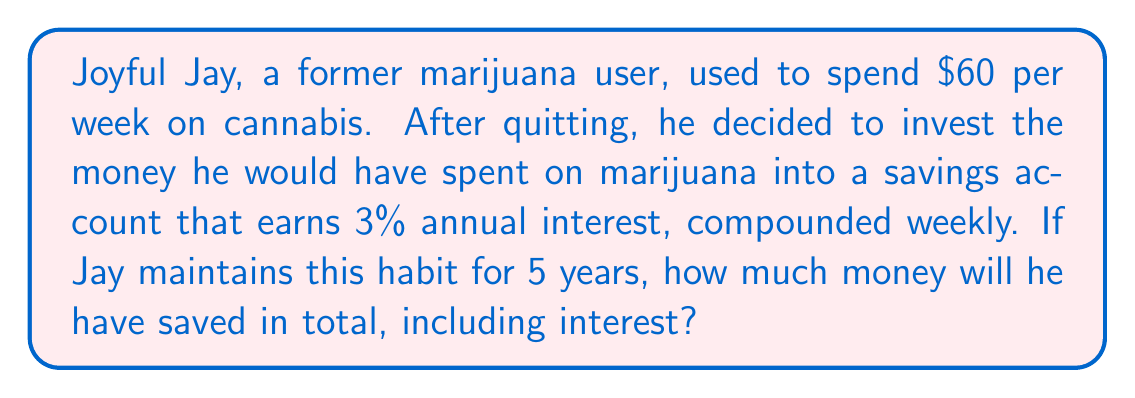Help me with this question. Let's break this problem down step-by-step:

1) First, we need to calculate the weekly savings:
   $60 per week

2) Now, we need to use the compound interest formula:
   $$A = P(1 + \frac{r}{n})^{nt}$$
   Where:
   $A$ = final amount
   $P$ = principal (initial investment)
   $r$ = annual interest rate (as a decimal)
   $n$ = number of times interest is compounded per year
   $t$ = number of years

3) In this case:
   $P$ = $60 (weekly deposit)
   $r$ = 0.03 (3% annual interest)
   $n$ = 52 (compounded weekly)
   $t$ = 5 years

4) However, we're dealing with regular deposits, not a one-time investment. For this, we need to use the future value of a series formula:
   $$A = \frac{P((1 + \frac{r}{n})^{nt} - 1)}{\frac{r}{n}}$$

5) Plugging in our values:
   $$A = \frac{60((1 + \frac{0.03}{52})^{52 * 5} - 1)}{\frac{0.03}{52}}$$

6) Calculating this:
   $$A = 16,499.12$$

Therefore, after 5 years, Jay will have saved $16,499.12.
Answer: $16,499.12 